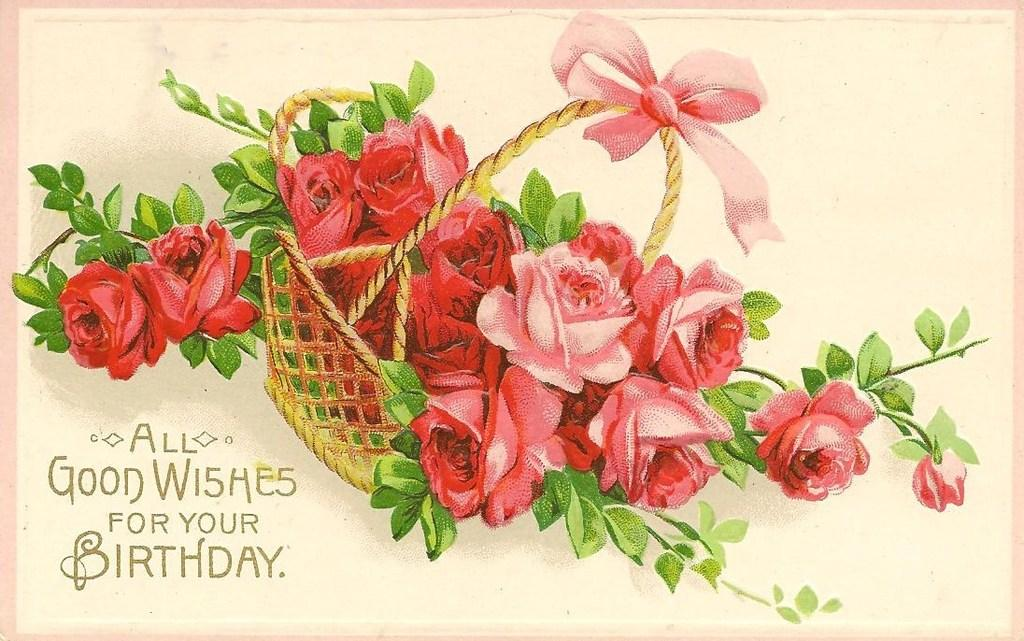What type of object is the image of? The image is a card. What is depicted on the card? There are plants and flowers in a basket on the card. Where is the text located on the card? The text is written on the card in the bottom left corner. How is the glue used in the image? There is no glue present in the image. What type of joke is written on the card? There is no joke written on the card; it contains text about plants and flowers in a basket. 